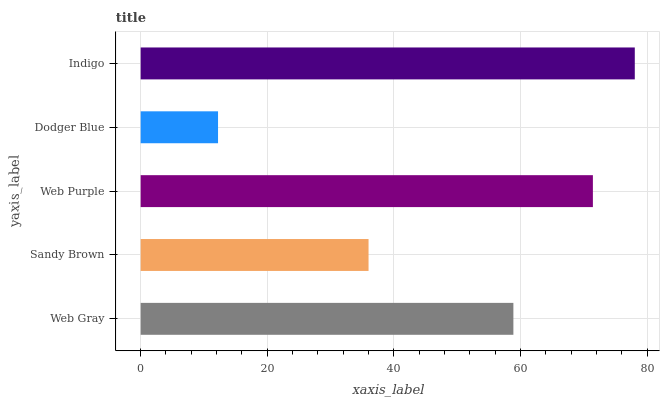Is Dodger Blue the minimum?
Answer yes or no. Yes. Is Indigo the maximum?
Answer yes or no. Yes. Is Sandy Brown the minimum?
Answer yes or no. No. Is Sandy Brown the maximum?
Answer yes or no. No. Is Web Gray greater than Sandy Brown?
Answer yes or no. Yes. Is Sandy Brown less than Web Gray?
Answer yes or no. Yes. Is Sandy Brown greater than Web Gray?
Answer yes or no. No. Is Web Gray less than Sandy Brown?
Answer yes or no. No. Is Web Gray the high median?
Answer yes or no. Yes. Is Web Gray the low median?
Answer yes or no. Yes. Is Sandy Brown the high median?
Answer yes or no. No. Is Sandy Brown the low median?
Answer yes or no. No. 